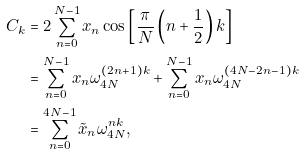Convert formula to latex. <formula><loc_0><loc_0><loc_500><loc_500>C _ { k } & = 2 \sum _ { n = 0 } ^ { N - 1 } x _ { n } \cos \left [ \frac { \pi } { N } \left ( n + \frac { 1 } { 2 } \right ) k \right ] \\ & = \sum _ { n = 0 } ^ { N - 1 } x _ { n } \omega _ { 4 N } ^ { ( 2 n + 1 ) k } + \sum _ { n = 0 } ^ { N - 1 } x _ { n } \omega _ { 4 N } ^ { ( 4 N - 2 n - 1 ) k } \\ & = \sum _ { n = 0 } ^ { 4 N - 1 } \tilde { x } _ { n } \omega _ { 4 N } ^ { n k } ,</formula> 